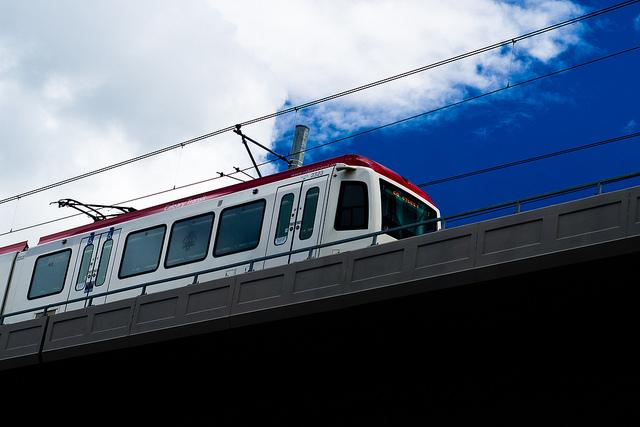Are the tracks on the ground?
Write a very short answer. No. What is the color of the sky?
Be succinct. Blue. How many windows on the train?
Quick response, please. 10. 